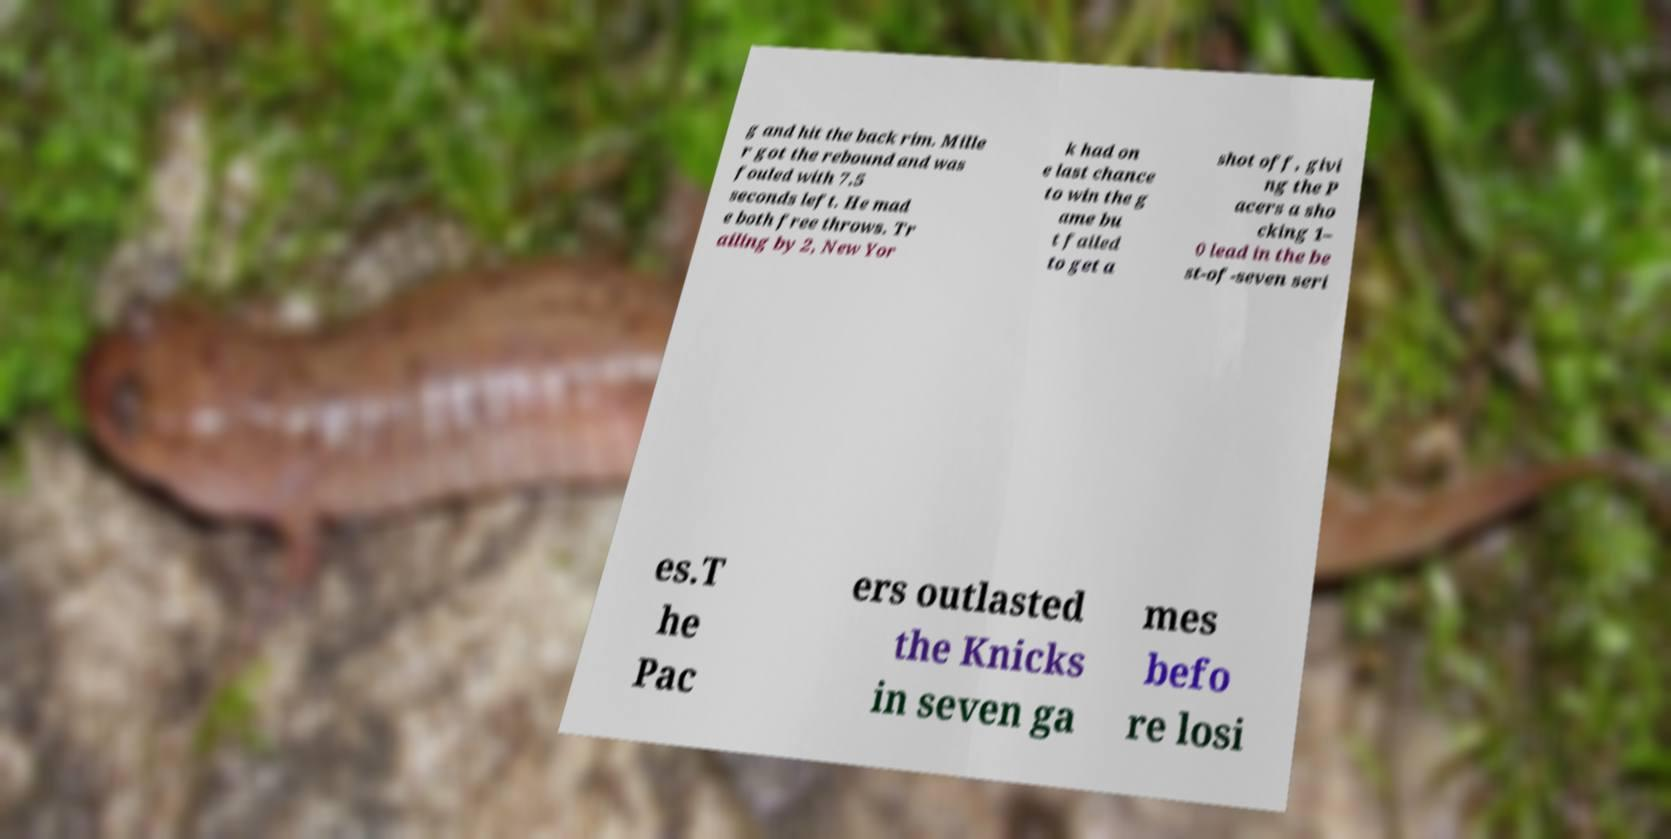Please identify and transcribe the text found in this image. g and hit the back rim. Mille r got the rebound and was fouled with 7.5 seconds left. He mad e both free throws. Tr ailing by 2, New Yor k had on e last chance to win the g ame bu t failed to get a shot off, givi ng the P acers a sho cking 1– 0 lead in the be st-of-seven seri es.T he Pac ers outlasted the Knicks in seven ga mes befo re losi 